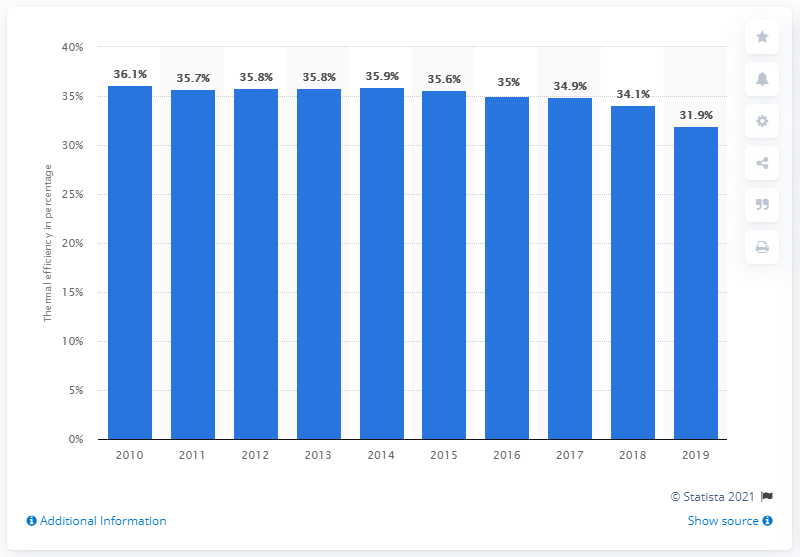Highlight a few significant elements in this photo. In 2019, the thermal efficiency of coal-fired stations was 31.9%. 